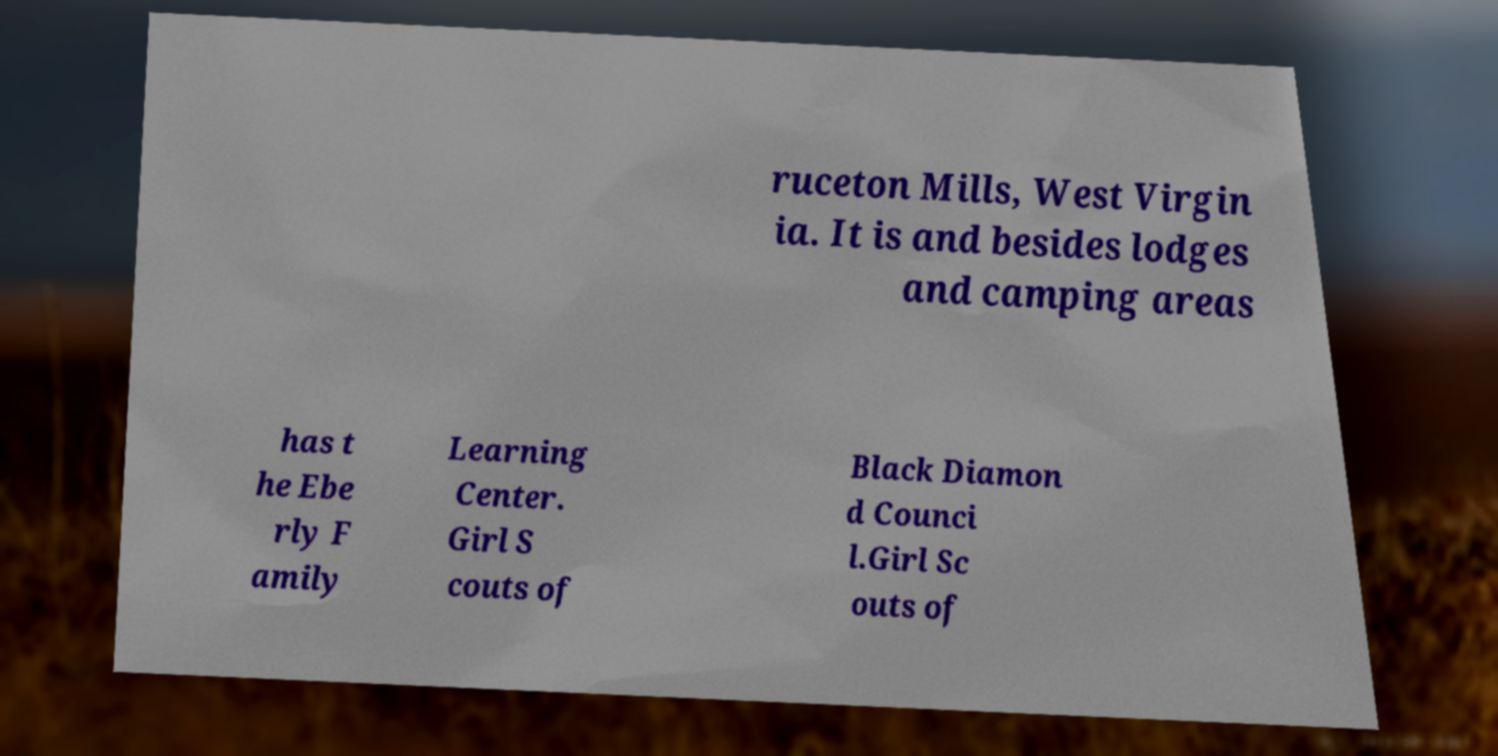Can you accurately transcribe the text from the provided image for me? ruceton Mills, West Virgin ia. It is and besides lodges and camping areas has t he Ebe rly F amily Learning Center. Girl S couts of Black Diamon d Counci l.Girl Sc outs of 